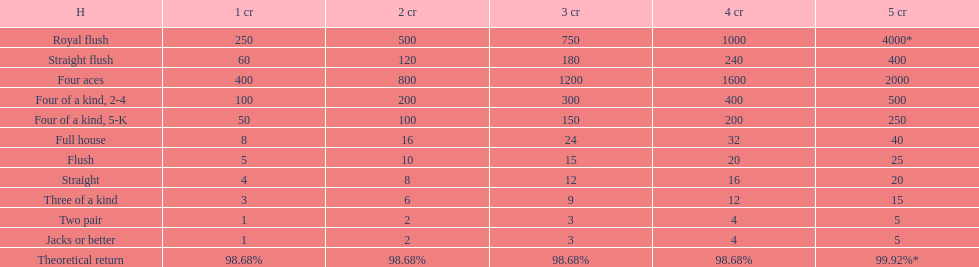What's the best type of four of a kind to win? Four of a kind, 2-4. 